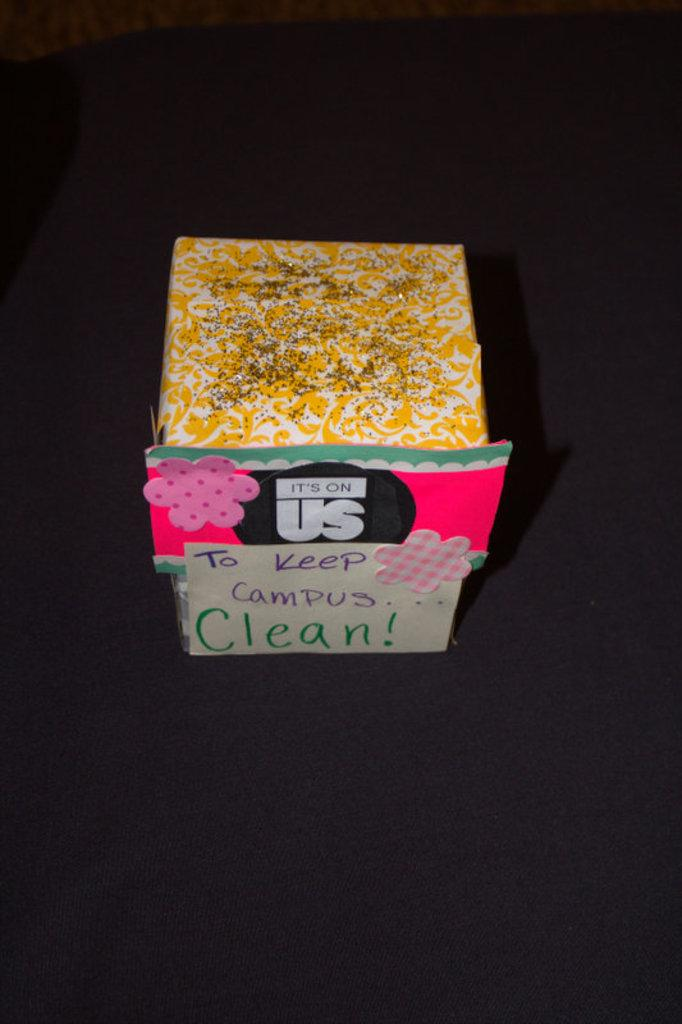<image>
Give a short and clear explanation of the subsequent image. The colorful, glittery, homemade box is intended for donations to keep the campus clean. 